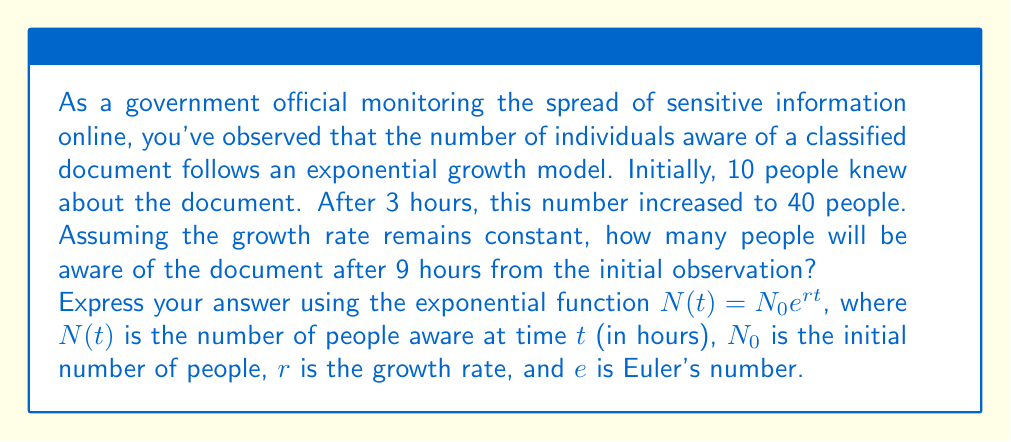Help me with this question. To solve this problem, we'll use the exponential growth function $N(t) = N_0 e^{rt}$ and follow these steps:

1. Identify the known values:
   $N_0 = 10$ (initial number of people)
   $N(3) = 40$ (number of people after 3 hours)
   $t = 9$ (time we need to calculate for)

2. Find the growth rate $r$ using the given information:
   $$40 = 10e^{3r}$$

3. Solve for $r$:
   $$4 = e^{3r}$$
   $$\ln(4) = 3r$$
   $$r = \frac{\ln(4)}{3} \approx 0.4621$$

4. Now that we have $r$, use the exponential growth function to find $N(9)$:
   $$N(9) = 10e^{0.4621 \cdot 9}$$

5. Calculate the result:
   $$N(9) = 10e^{4.1589} \approx 640.73$$

Therefore, after 9 hours, approximately 641 people will be aware of the classified document.
Answer: $N(9) = 10e^{0.4621 \cdot 9} \approx 641$ people 